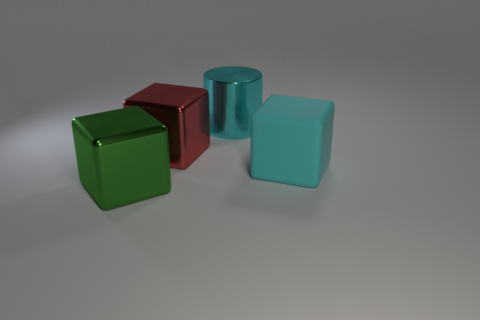Is there anything else that has the same shape as the large cyan shiny thing?
Provide a succinct answer. No. Is the shape of the big green object the same as the red shiny object?
Keep it short and to the point. Yes. Is there anything else that has the same material as the cyan block?
Your answer should be very brief. No. Is the color of the large metallic object right of the red metal block the same as the block right of the large red metallic cube?
Provide a succinct answer. Yes. What number of large objects are both right of the large cyan shiny cylinder and left of the big red metallic cube?
Ensure brevity in your answer.  0. How many other things are the same shape as the big matte thing?
Provide a succinct answer. 2. Is the number of big rubber cubes right of the big red cube greater than the number of tiny yellow cubes?
Offer a terse response. Yes. What color is the metal cube that is behind the cyan cube?
Ensure brevity in your answer.  Red. What is the size of the rubber cube that is the same color as the shiny cylinder?
Your answer should be very brief. Large. What number of metal things are large cyan cylinders or green objects?
Offer a terse response. 2. 